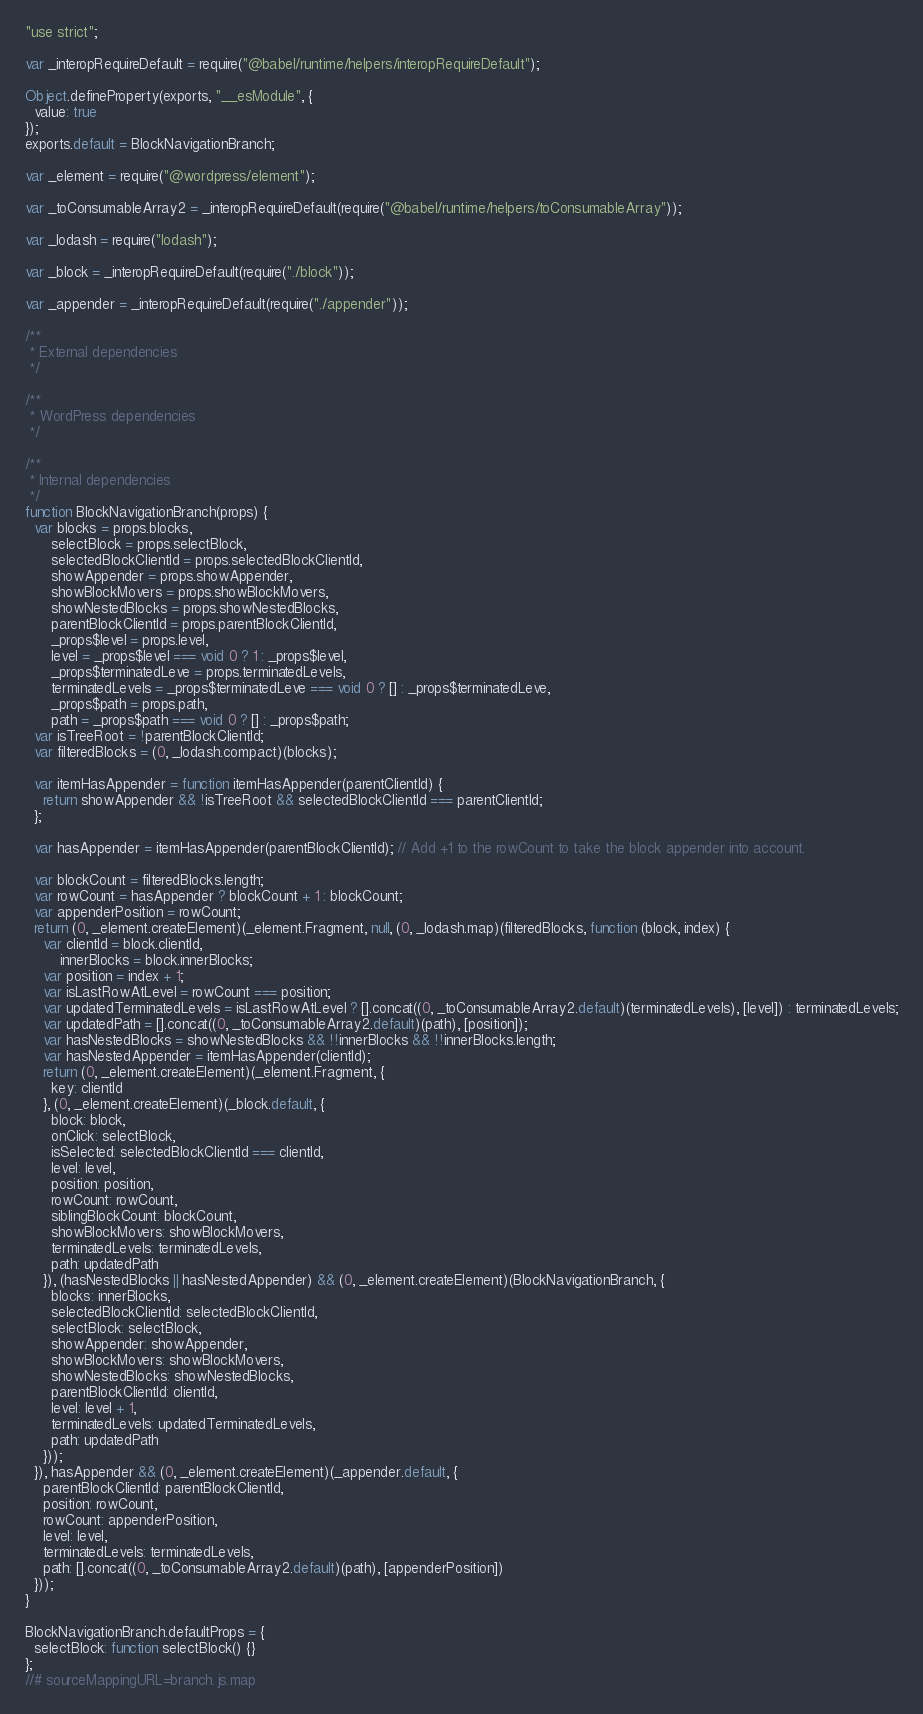Convert code to text. <code><loc_0><loc_0><loc_500><loc_500><_JavaScript_>"use strict";

var _interopRequireDefault = require("@babel/runtime/helpers/interopRequireDefault");

Object.defineProperty(exports, "__esModule", {
  value: true
});
exports.default = BlockNavigationBranch;

var _element = require("@wordpress/element");

var _toConsumableArray2 = _interopRequireDefault(require("@babel/runtime/helpers/toConsumableArray"));

var _lodash = require("lodash");

var _block = _interopRequireDefault(require("./block"));

var _appender = _interopRequireDefault(require("./appender"));

/**
 * External dependencies
 */

/**
 * WordPress dependencies
 */

/**
 * Internal dependencies
 */
function BlockNavigationBranch(props) {
  var blocks = props.blocks,
      selectBlock = props.selectBlock,
      selectedBlockClientId = props.selectedBlockClientId,
      showAppender = props.showAppender,
      showBlockMovers = props.showBlockMovers,
      showNestedBlocks = props.showNestedBlocks,
      parentBlockClientId = props.parentBlockClientId,
      _props$level = props.level,
      level = _props$level === void 0 ? 1 : _props$level,
      _props$terminatedLeve = props.terminatedLevels,
      terminatedLevels = _props$terminatedLeve === void 0 ? [] : _props$terminatedLeve,
      _props$path = props.path,
      path = _props$path === void 0 ? [] : _props$path;
  var isTreeRoot = !parentBlockClientId;
  var filteredBlocks = (0, _lodash.compact)(blocks);

  var itemHasAppender = function itemHasAppender(parentClientId) {
    return showAppender && !isTreeRoot && selectedBlockClientId === parentClientId;
  };

  var hasAppender = itemHasAppender(parentBlockClientId); // Add +1 to the rowCount to take the block appender into account.

  var blockCount = filteredBlocks.length;
  var rowCount = hasAppender ? blockCount + 1 : blockCount;
  var appenderPosition = rowCount;
  return (0, _element.createElement)(_element.Fragment, null, (0, _lodash.map)(filteredBlocks, function (block, index) {
    var clientId = block.clientId,
        innerBlocks = block.innerBlocks;
    var position = index + 1;
    var isLastRowAtLevel = rowCount === position;
    var updatedTerminatedLevels = isLastRowAtLevel ? [].concat((0, _toConsumableArray2.default)(terminatedLevels), [level]) : terminatedLevels;
    var updatedPath = [].concat((0, _toConsumableArray2.default)(path), [position]);
    var hasNestedBlocks = showNestedBlocks && !!innerBlocks && !!innerBlocks.length;
    var hasNestedAppender = itemHasAppender(clientId);
    return (0, _element.createElement)(_element.Fragment, {
      key: clientId
    }, (0, _element.createElement)(_block.default, {
      block: block,
      onClick: selectBlock,
      isSelected: selectedBlockClientId === clientId,
      level: level,
      position: position,
      rowCount: rowCount,
      siblingBlockCount: blockCount,
      showBlockMovers: showBlockMovers,
      terminatedLevels: terminatedLevels,
      path: updatedPath
    }), (hasNestedBlocks || hasNestedAppender) && (0, _element.createElement)(BlockNavigationBranch, {
      blocks: innerBlocks,
      selectedBlockClientId: selectedBlockClientId,
      selectBlock: selectBlock,
      showAppender: showAppender,
      showBlockMovers: showBlockMovers,
      showNestedBlocks: showNestedBlocks,
      parentBlockClientId: clientId,
      level: level + 1,
      terminatedLevels: updatedTerminatedLevels,
      path: updatedPath
    }));
  }), hasAppender && (0, _element.createElement)(_appender.default, {
    parentBlockClientId: parentBlockClientId,
    position: rowCount,
    rowCount: appenderPosition,
    level: level,
    terminatedLevels: terminatedLevels,
    path: [].concat((0, _toConsumableArray2.default)(path), [appenderPosition])
  }));
}

BlockNavigationBranch.defaultProps = {
  selectBlock: function selectBlock() {}
};
//# sourceMappingURL=branch.js.map</code> 